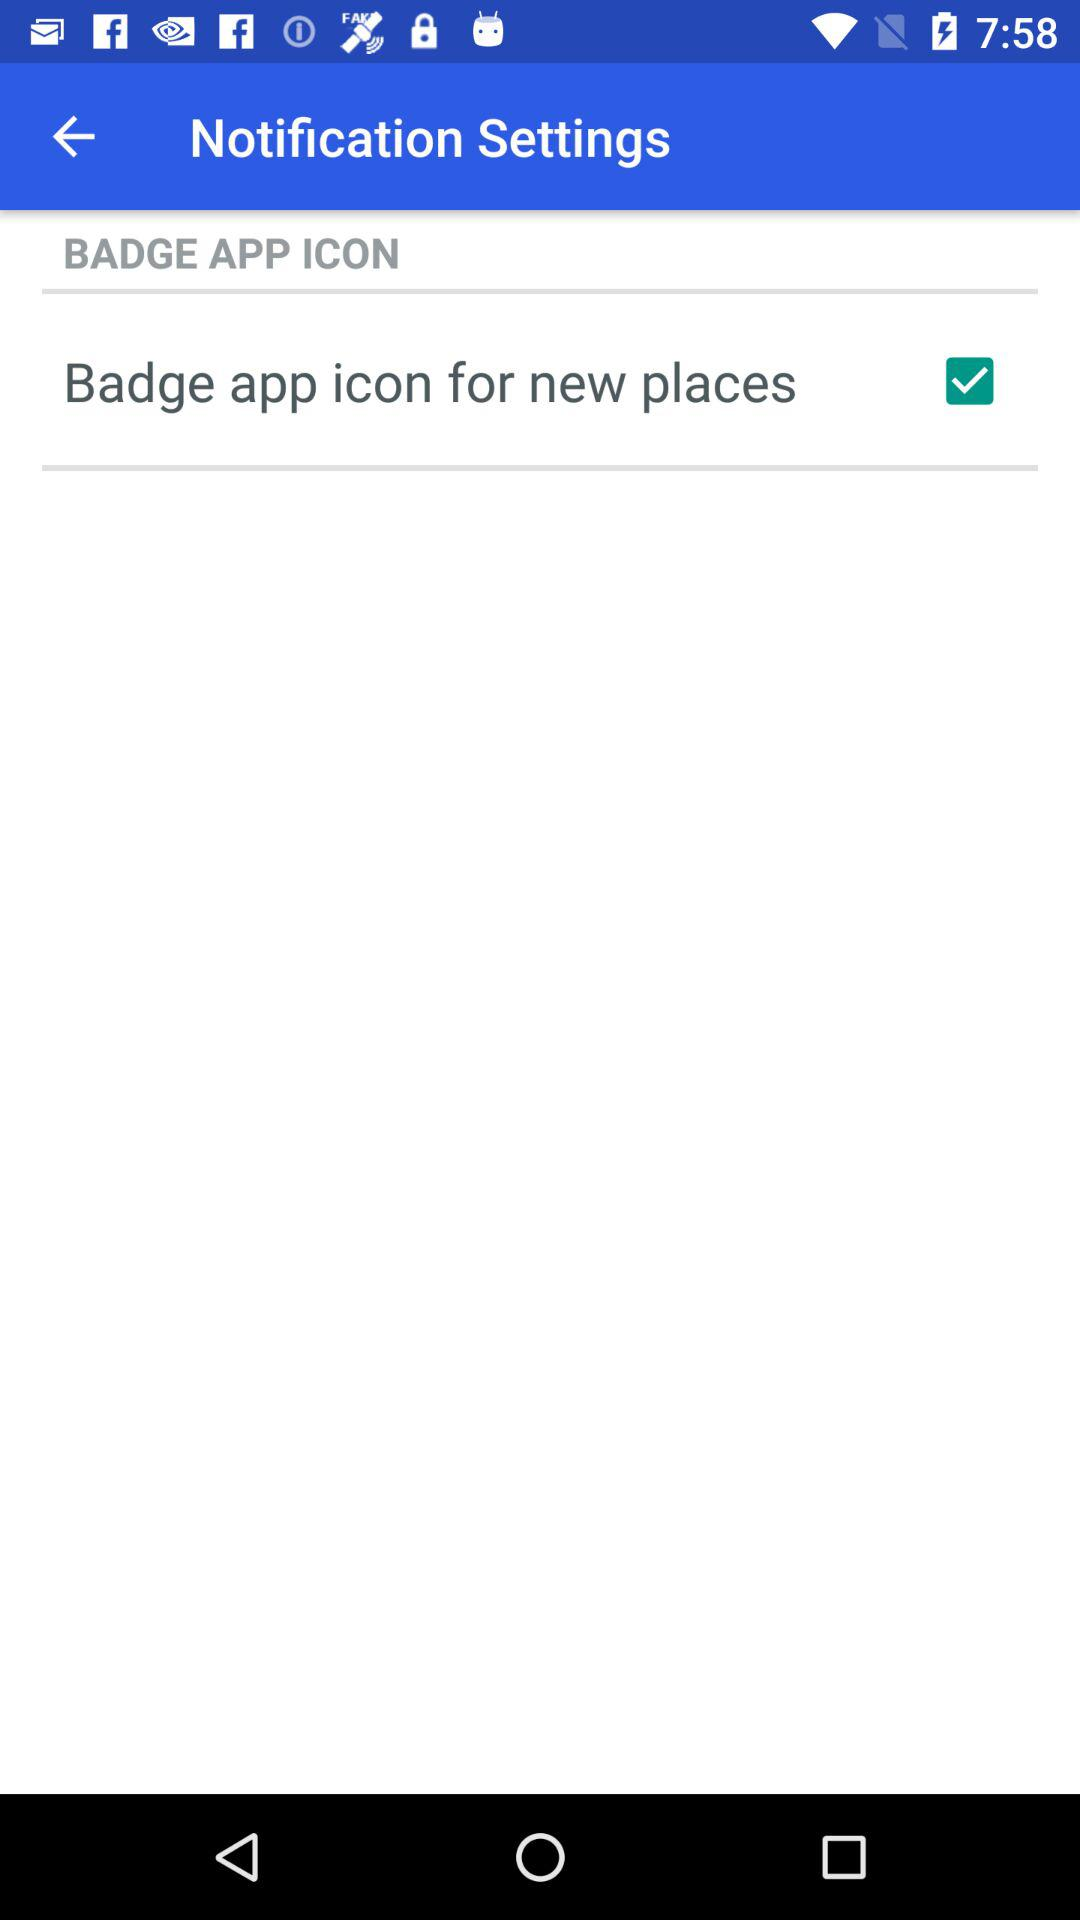What is the status of the "Badge app icon for new places"? The status of the "Badge app icon for new places" is "on". 